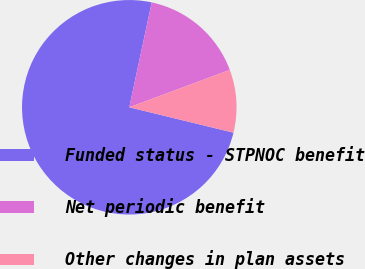Convert chart to OTSL. <chart><loc_0><loc_0><loc_500><loc_500><pie_chart><fcel>Funded status - STPNOC benefit<fcel>Net periodic benefit<fcel>Other changes in plan assets<nl><fcel>74.56%<fcel>15.98%<fcel>9.47%<nl></chart> 